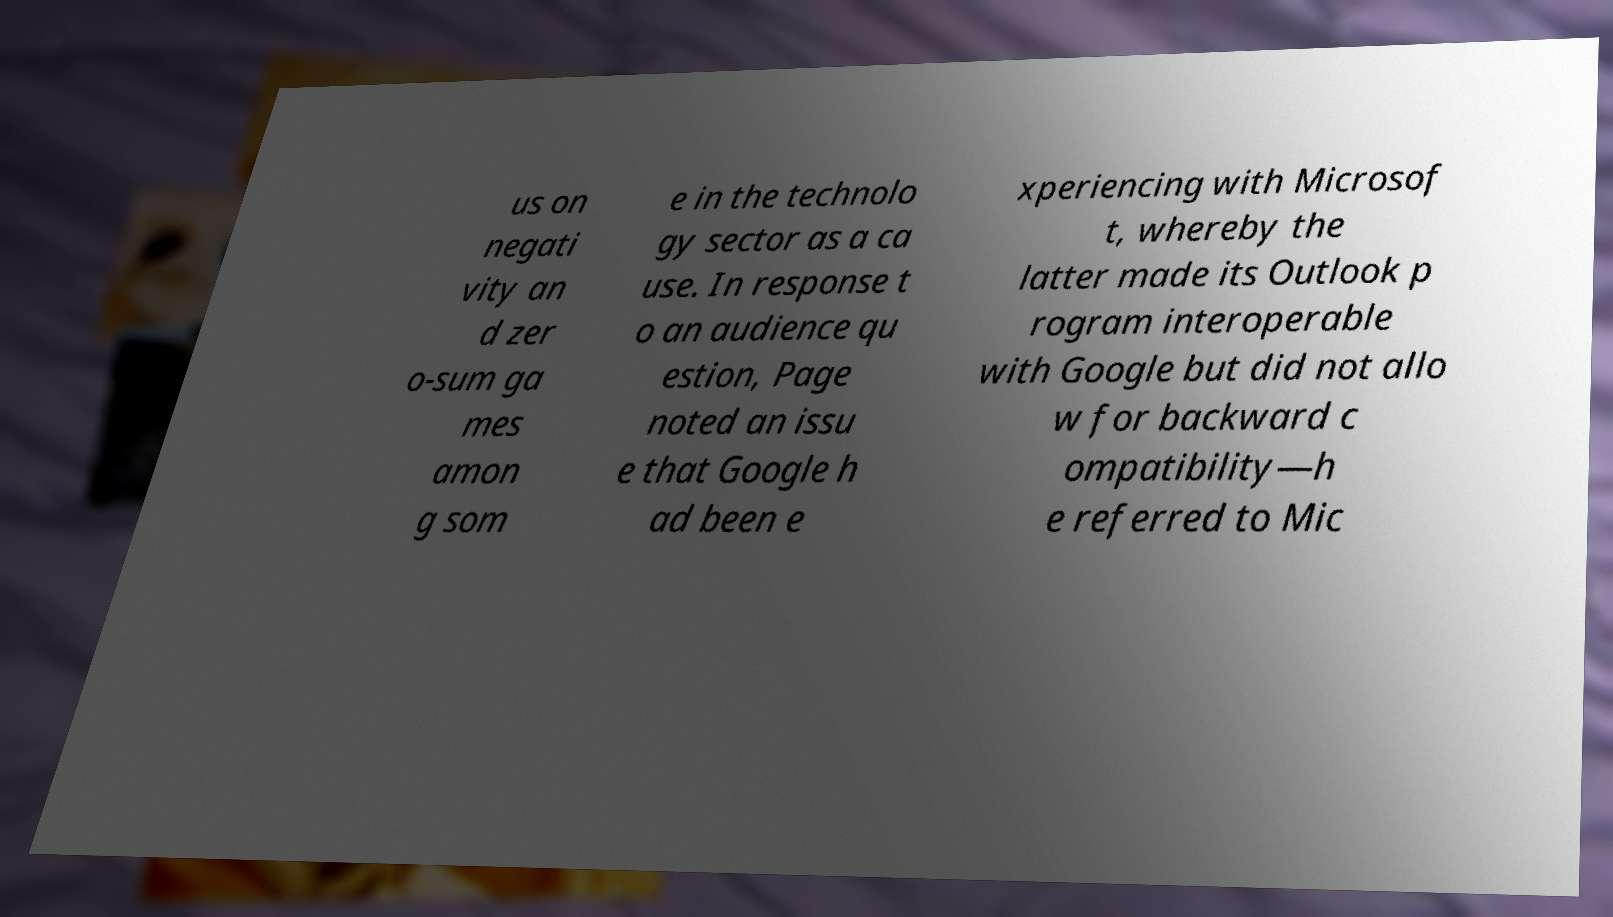Please read and relay the text visible in this image. What does it say? us on negati vity an d zer o-sum ga mes amon g som e in the technolo gy sector as a ca use. In response t o an audience qu estion, Page noted an issu e that Google h ad been e xperiencing with Microsof t, whereby the latter made its Outlook p rogram interoperable with Google but did not allo w for backward c ompatibility—h e referred to Mic 